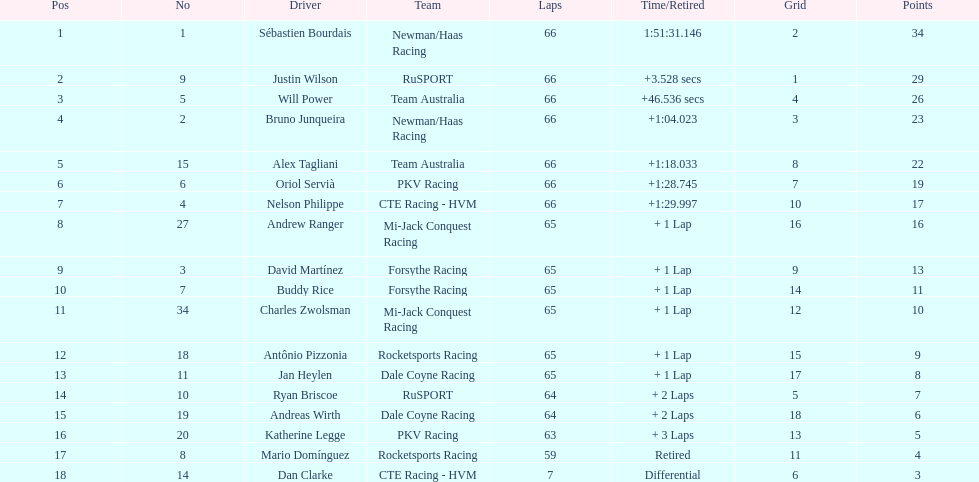745? Nelson Philippe. Can you parse all the data within this table? {'header': ['Pos', 'No', 'Driver', 'Team', 'Laps', 'Time/Retired', 'Grid', 'Points'], 'rows': [['1', '1', 'Sébastien Bourdais', 'Newman/Haas Racing', '66', '1:51:31.146', '2', '34'], ['2', '9', 'Justin Wilson', 'RuSPORT', '66', '+3.528 secs', '1', '29'], ['3', '5', 'Will Power', 'Team Australia', '66', '+46.536 secs', '4', '26'], ['4', '2', 'Bruno Junqueira', 'Newman/Haas Racing', '66', '+1:04.023', '3', '23'], ['5', '15', 'Alex Tagliani', 'Team Australia', '66', '+1:18.033', '8', '22'], ['6', '6', 'Oriol Servià', 'PKV Racing', '66', '+1:28.745', '7', '19'], ['7', '4', 'Nelson Philippe', 'CTE Racing - HVM', '66', '+1:29.997', '10', '17'], ['8', '27', 'Andrew Ranger', 'Mi-Jack Conquest Racing', '65', '+ 1 Lap', '16', '16'], ['9', '3', 'David Martínez', 'Forsythe Racing', '65', '+ 1 Lap', '9', '13'], ['10', '7', 'Buddy Rice', 'Forsythe Racing', '65', '+ 1 Lap', '14', '11'], ['11', '34', 'Charles Zwolsman', 'Mi-Jack Conquest Racing', '65', '+ 1 Lap', '12', '10'], ['12', '18', 'Antônio Pizzonia', 'Rocketsports Racing', '65', '+ 1 Lap', '15', '9'], ['13', '11', 'Jan Heylen', 'Dale Coyne Racing', '65', '+ 1 Lap', '17', '8'], ['14', '10', 'Ryan Briscoe', 'RuSPORT', '64', '+ 2 Laps', '5', '7'], ['15', '19', 'Andreas Wirth', 'Dale Coyne Racing', '64', '+ 2 Laps', '18', '6'], ['16', '20', 'Katherine Legge', 'PKV Racing', '63', '+ 3 Laps', '13', '5'], ['17', '8', 'Mario Domínguez', 'Rocketsports Racing', '59', 'Retired', '11', '4'], ['18', '14', 'Dan Clarke', 'CTE Racing - HVM', '7', 'Differential', '6', '3']]} 